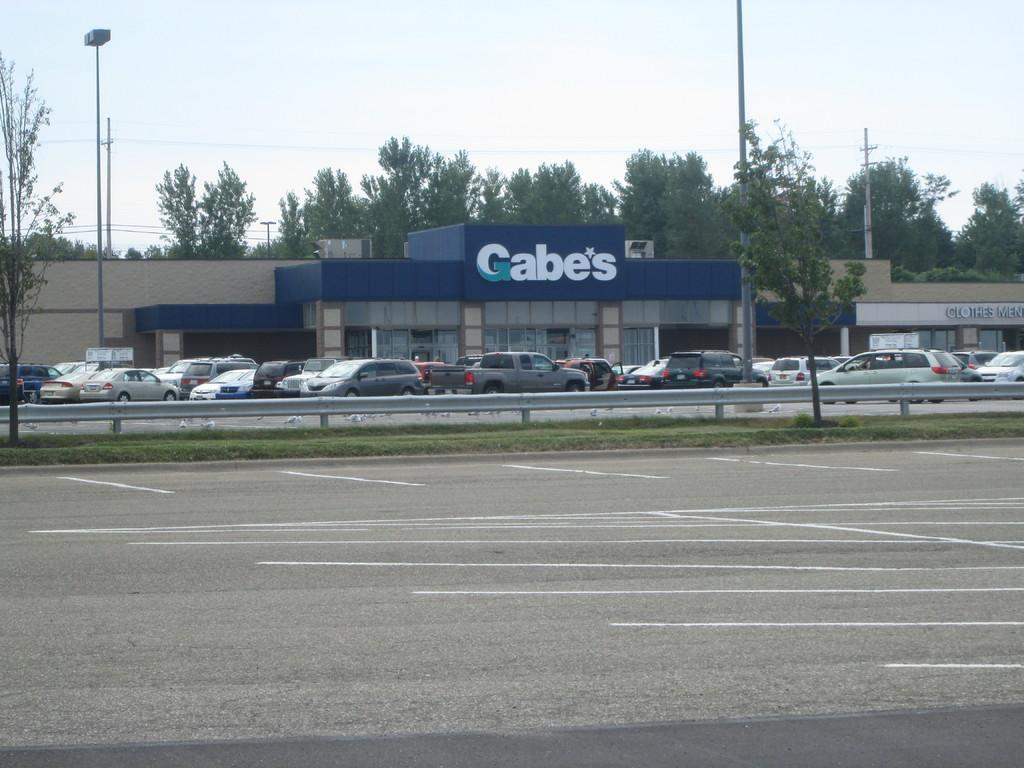In one or two sentences, can you explain what this image depicts? In this image, we can see some cars in front of the building. There is a road at the bottom of the image. There are poles on the left and on the right side of the image. There are some trees in the middle of the image. There is a sky at the top of the image. 